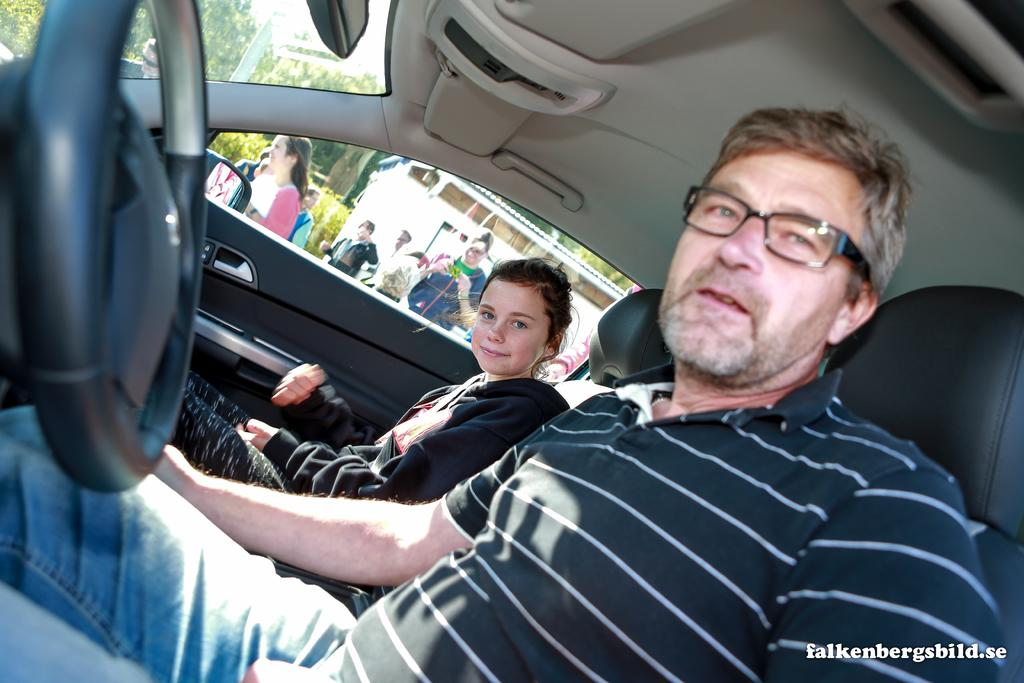Who are the people in the image? There is a man and a girl in the image. What are they doing in the image? Both the man and the girl are sitting in a car and posing for a camera. Can you describe the setting of the image? They are sitting in a car, and there are people at a distance behind them. What type of floor can be seen in the image? There is no floor visible in the image, as the subjects are sitting in a car. 